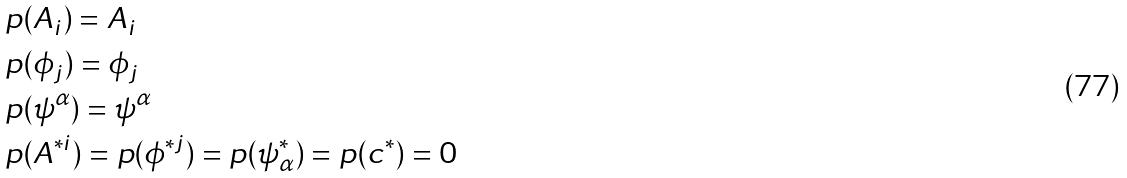<formula> <loc_0><loc_0><loc_500><loc_500>& p ( A _ { i } ) = A _ { i } \\ & p ( \phi _ { j } ) = \phi _ { j } \\ & p ( \psi ^ { \alpha } ) = \psi ^ { \alpha } \\ & p ( A ^ { * i } ) = p ( \phi ^ { * j } ) = p ( \psi ^ { * } _ { \alpha } ) = p ( c ^ { * } ) = 0</formula> 